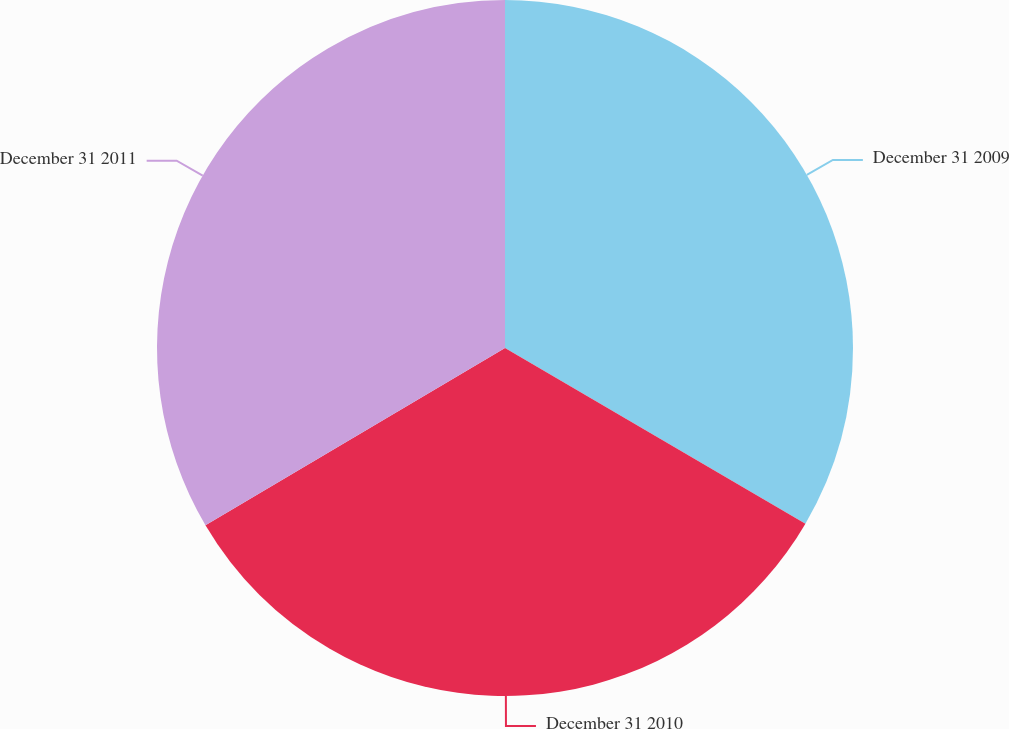Convert chart to OTSL. <chart><loc_0><loc_0><loc_500><loc_500><pie_chart><fcel>December 31 2009<fcel>December 31 2010<fcel>December 31 2011<nl><fcel>33.42%<fcel>33.08%<fcel>33.5%<nl></chart> 